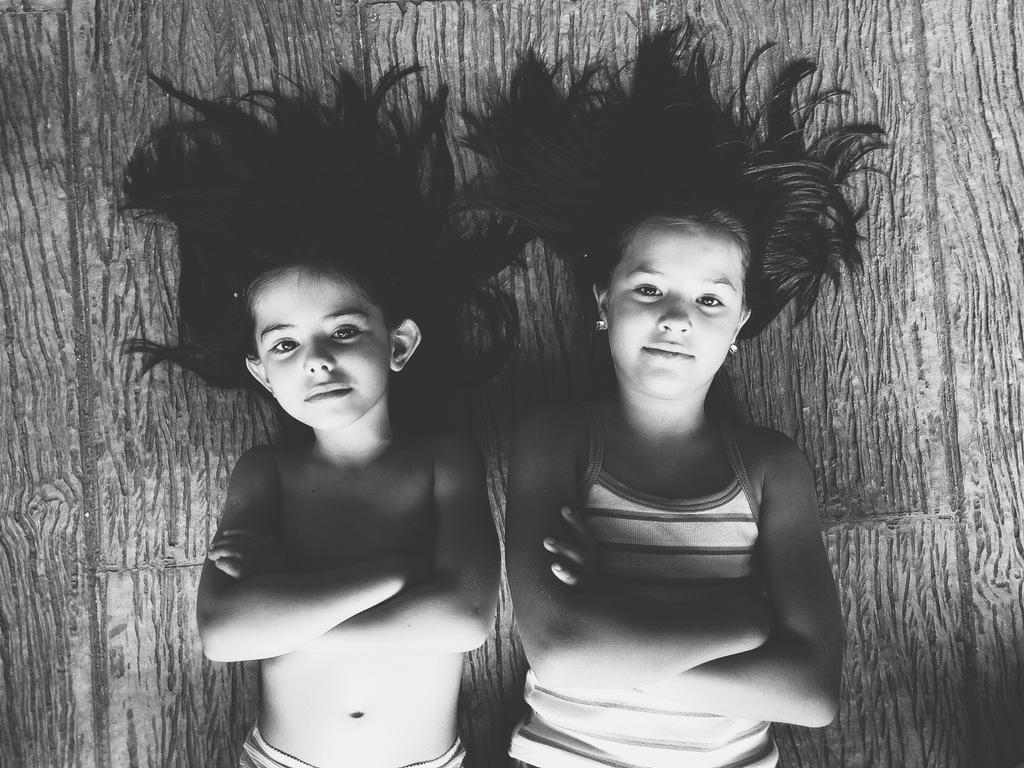Please provide a concise description of this image. In this picture we can see two kids, they are lying and it is a black and white photography. 